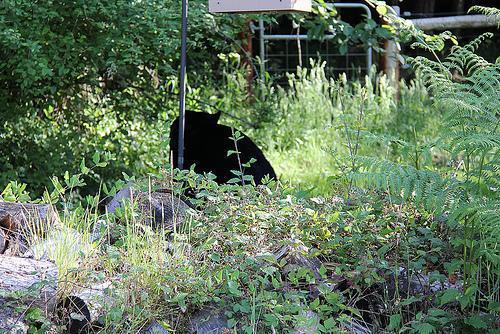How many cats are there?
Give a very brief answer. 1. 